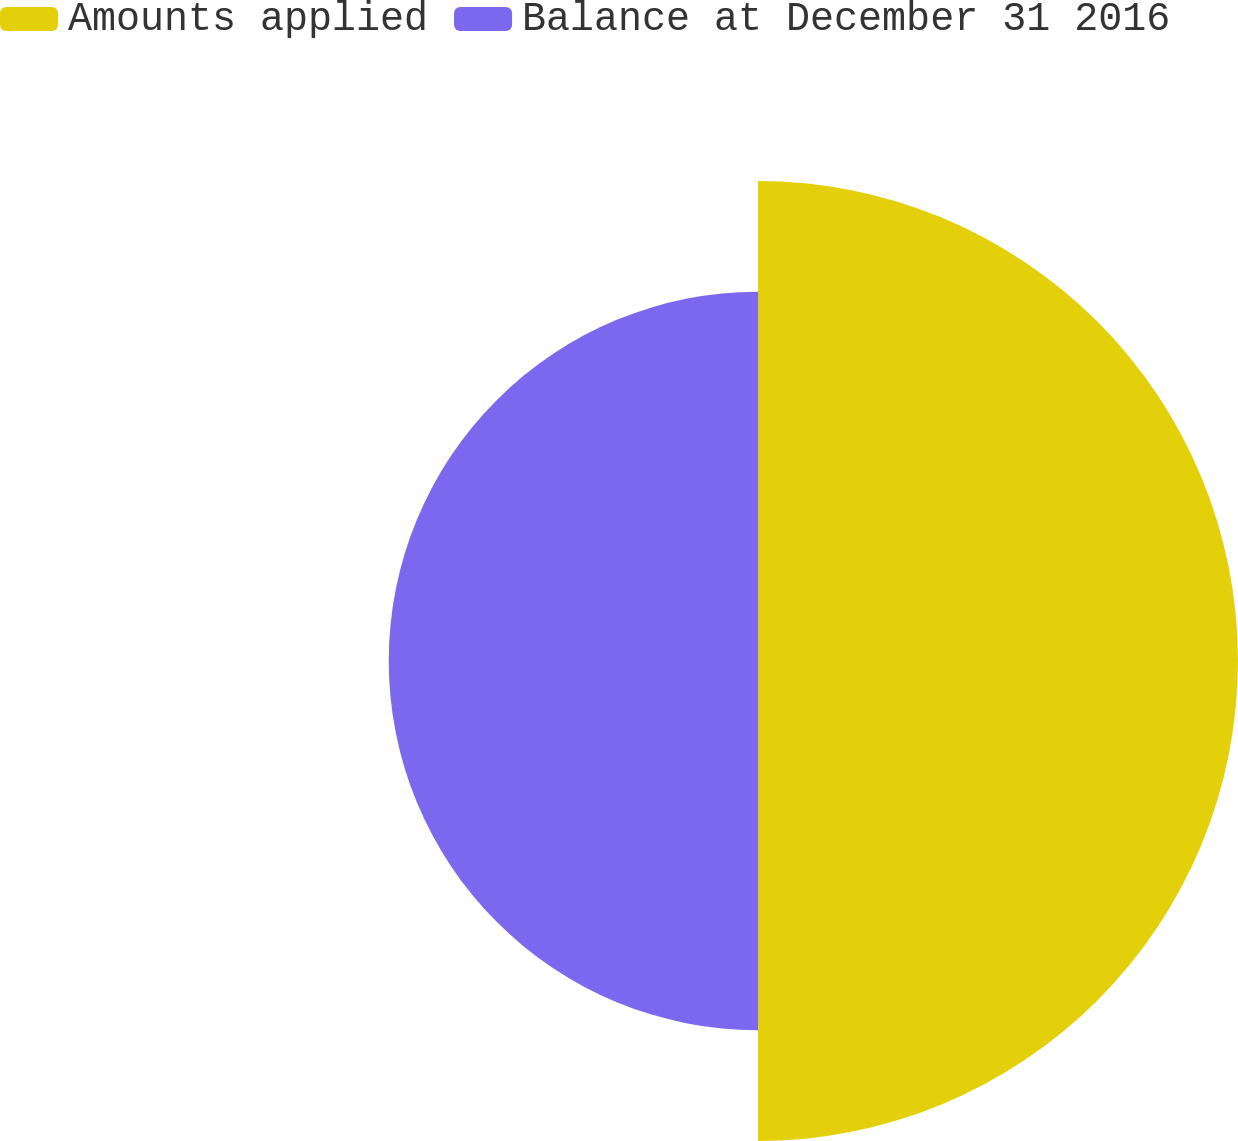<chart> <loc_0><loc_0><loc_500><loc_500><pie_chart><fcel>Amounts applied<fcel>Balance at December 31 2016<nl><fcel>56.52%<fcel>43.48%<nl></chart> 